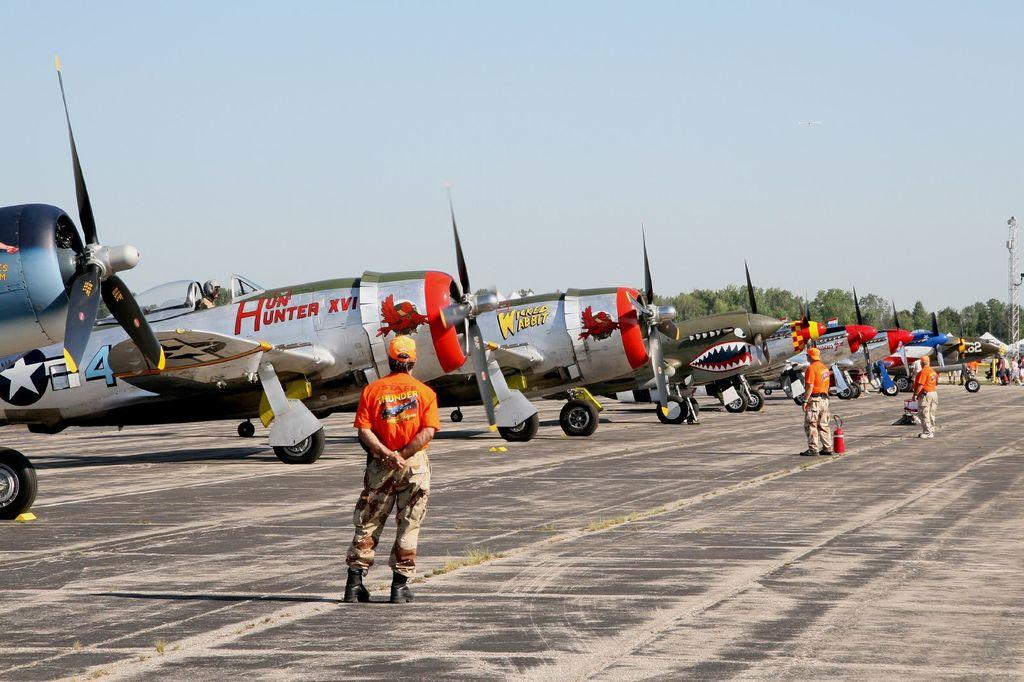Provide a one-sentence caption for the provided image. An airplane named Hun' Hunter XVI sits on a runway next to several other planes. 